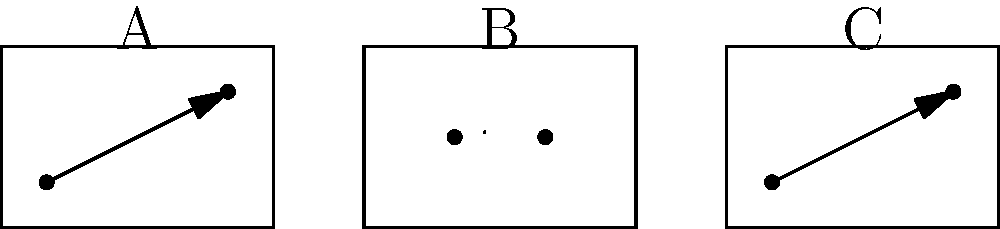In the storyboard sketch above, which frame(s) utilize(s) diagonal composition to create a sense of dynamic movement or tension? How does this compositional choice contribute to the overall narrative flow of the scene? To analyze the scene composition using the storyboard sketches, we need to examine each frame:

1. Frame A:
   - Contains a diagonal line from bottom-left to top-right
   - The diagonal is emphasized with an arrow
   - Diagonal lines create a sense of movement and dynamism

2. Frame B:
   - Contains a horizontal line in the center
   - Horizontal lines typically suggest stability or calmness

3. Frame C:
   - Contains a diagonal line from bottom-left to top-right
   - The diagonal is emphasized with an arrow
   - Similar to Frame A, this creates a sense of movement

Diagonal compositions (frames A and C) create visual interest and imply motion or tension. They guide the viewer's eye across the frame, suggesting action or change. In contrast, the horizontal composition in frame B implies a moment of stability or pause.

The narrative flow is enhanced by this composition:
1. Frame A introduces dynamic movement
2. Frame B provides a brief moment of stability or reflection
3. Frame C reintroduces movement, potentially escalating the action

This sequence creates a rhythm of tension-release-tension, which can be effective in maintaining viewer engagement and driving the story forward.
Answer: Frames A and C; they create dynamic movement and tension, contributing to a rhythm of tension-release-tension in the narrative flow. 